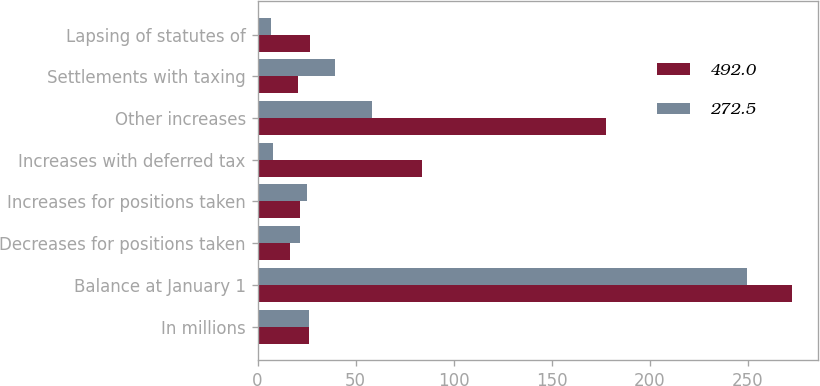Convert chart. <chart><loc_0><loc_0><loc_500><loc_500><stacked_bar_chart><ecel><fcel>In millions<fcel>Balance at January 1<fcel>Decreases for positions taken<fcel>Increases for positions taken<fcel>Increases with deferred tax<fcel>Other increases<fcel>Settlements with taxing<fcel>Lapsing of statutes of<nl><fcel>492<fcel>26<fcel>272.5<fcel>16.4<fcel>21.8<fcel>83.9<fcel>178<fcel>20.8<fcel>27<nl><fcel>272.5<fcel>26<fcel>249.7<fcel>21.8<fcel>25<fcel>7.7<fcel>58.2<fcel>39.5<fcel>6.8<nl></chart> 